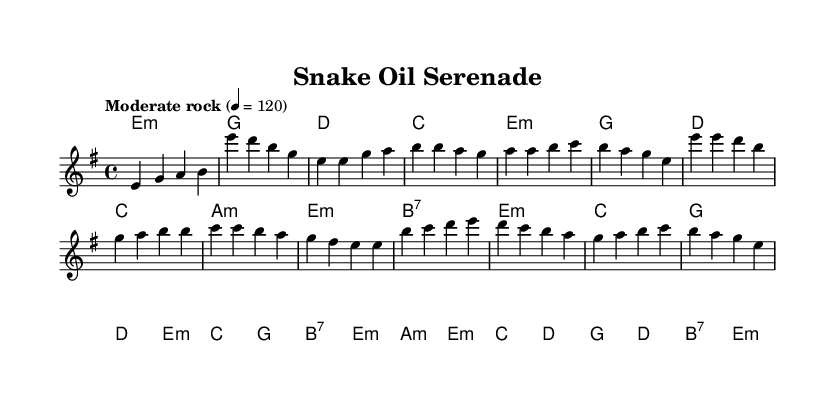What is the key signature of this music? The key signature is E minor, which has one sharp (F#). It can be identified by looking for the sharp sign placed on the F line in the staff at the beginning of the piece.
Answer: E minor What is the time signature of this music? The time signature is 4/4, which indicates four beats in a measure and a quarter note gets one beat. This information is usually found at the beginning of the score right after the key signature.
Answer: 4/4 What is the tempo marking of this music? The tempo marking is "Moderate rock," which signifies a moderate speed typically used in rock music. This marking is found at the beginning of the piece, indicating how quickly the music should be performed.
Answer: Moderate rock How many measures are there in the verse? The verse consists of four measures. To find this, you can count the measures marked by bar lines in the verse section, which is clearly defined in the melody part of the score.
Answer: Four measures What is the first lyric in the chorus? The first lyric in the chorus is "Snake oil serenade." This can be determined by looking at the lyrics written under the notes of the chorus section, where the first word corresponds to the first note.
Answer: Snake oil serenade What chord follows the first verse phrase? The chord that follows the first verse phrase is G. This is determined by the chord symbols placed above the melody line, which indicate the harmonies to be played alongside the melody.
Answer: G How many different chords are used in the bridge? There are six different chords used in the bridge section. By analyzing the chord symbols listed above the melody during the bridge passage, one can tally the distinct chords encountered.
Answer: Six chords 